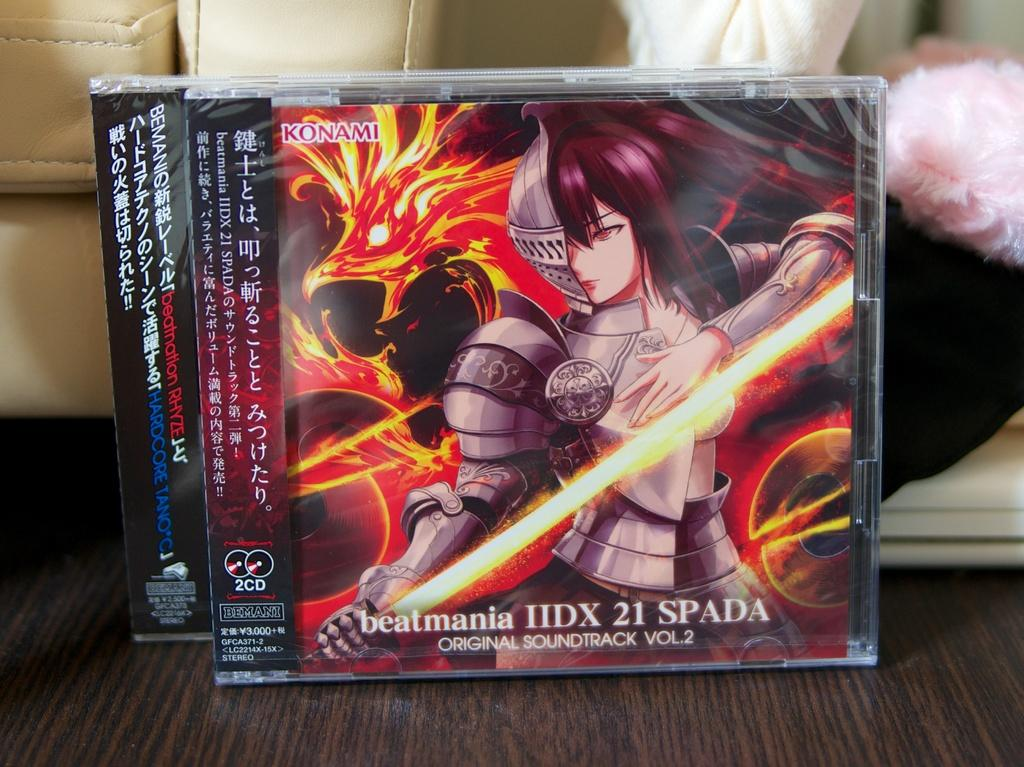<image>
Share a concise interpretation of the image provided. Video game cover showing a woman holding a sword titled beatmania. 